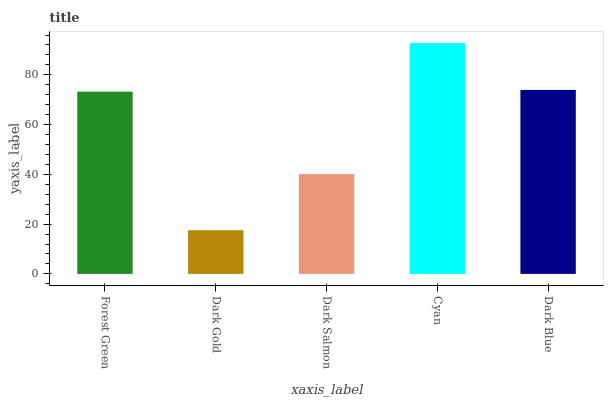Is Dark Gold the minimum?
Answer yes or no. Yes. Is Cyan the maximum?
Answer yes or no. Yes. Is Dark Salmon the minimum?
Answer yes or no. No. Is Dark Salmon the maximum?
Answer yes or no. No. Is Dark Salmon greater than Dark Gold?
Answer yes or no. Yes. Is Dark Gold less than Dark Salmon?
Answer yes or no. Yes. Is Dark Gold greater than Dark Salmon?
Answer yes or no. No. Is Dark Salmon less than Dark Gold?
Answer yes or no. No. Is Forest Green the high median?
Answer yes or no. Yes. Is Forest Green the low median?
Answer yes or no. Yes. Is Dark Blue the high median?
Answer yes or no. No. Is Dark Gold the low median?
Answer yes or no. No. 